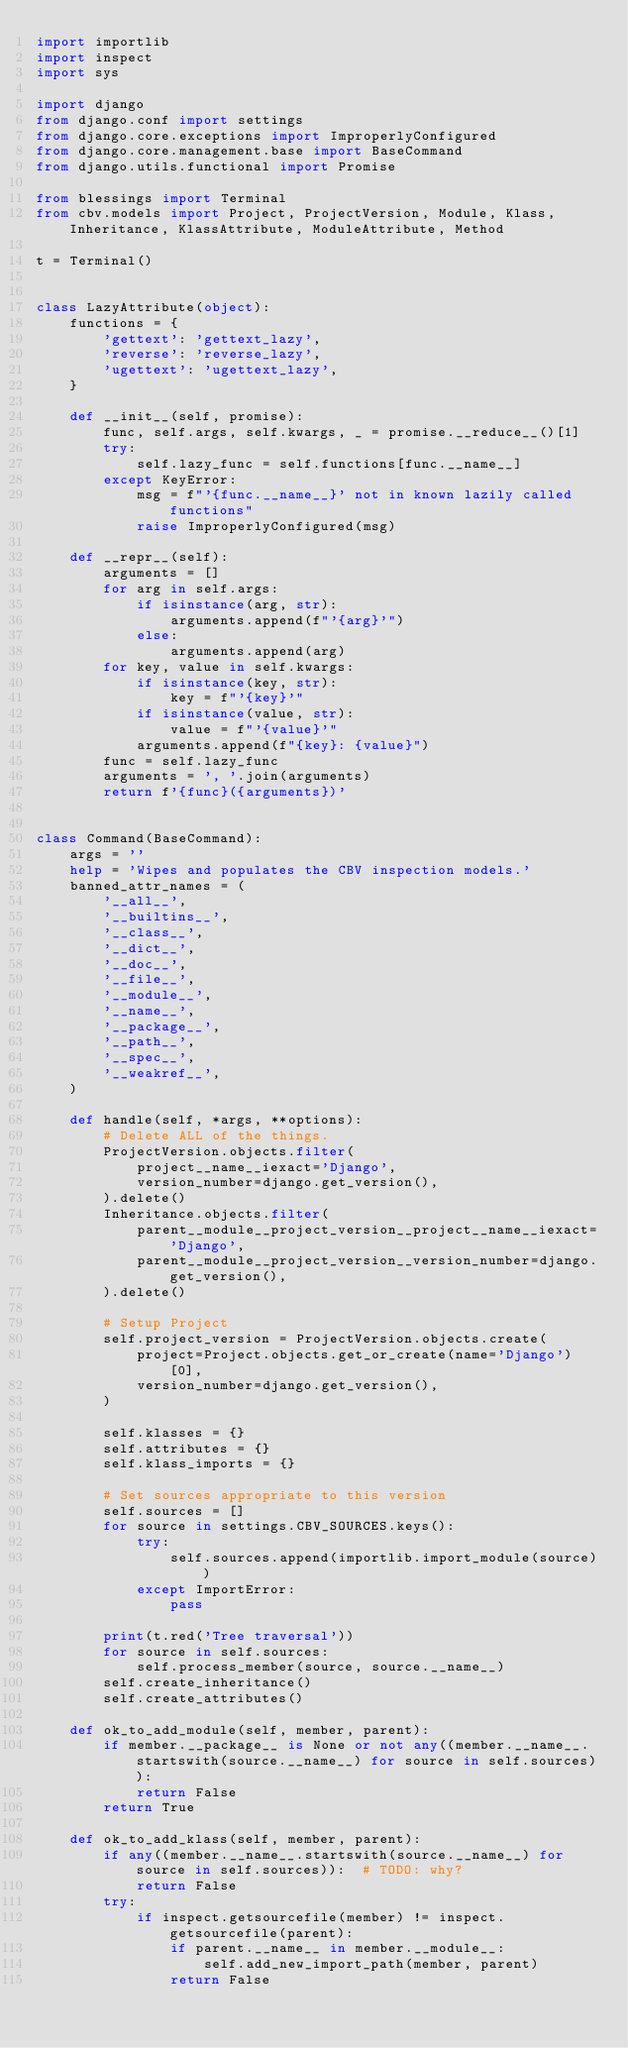<code> <loc_0><loc_0><loc_500><loc_500><_Python_>import importlib
import inspect
import sys

import django
from django.conf import settings
from django.core.exceptions import ImproperlyConfigured
from django.core.management.base import BaseCommand
from django.utils.functional import Promise

from blessings import Terminal
from cbv.models import Project, ProjectVersion, Module, Klass, Inheritance, KlassAttribute, ModuleAttribute, Method

t = Terminal()


class LazyAttribute(object):
    functions = {
        'gettext': 'gettext_lazy',
        'reverse': 'reverse_lazy',
        'ugettext': 'ugettext_lazy',
    }

    def __init__(self, promise):
        func, self.args, self.kwargs, _ = promise.__reduce__()[1]
        try:
            self.lazy_func = self.functions[func.__name__]
        except KeyError:
            msg = f"'{func.__name__}' not in known lazily called functions"
            raise ImproperlyConfigured(msg)

    def __repr__(self):
        arguments = []
        for arg in self.args:
            if isinstance(arg, str):
                arguments.append(f"'{arg}'")
            else:
                arguments.append(arg)
        for key, value in self.kwargs:
            if isinstance(key, str):
                key = f"'{key}'"
            if isinstance(value, str):
                value = f"'{value}'"
            arguments.append(f"{key}: {value}")
        func = self.lazy_func
        arguments = ', '.join(arguments)
        return f'{func}({arguments})'


class Command(BaseCommand):
    args = ''
    help = 'Wipes and populates the CBV inspection models.'
    banned_attr_names = (
        '__all__',
        '__builtins__',
        '__class__',
        '__dict__',
        '__doc__',
        '__file__',
        '__module__',
        '__name__',
        '__package__',
        '__path__',
        '__spec__',
        '__weakref__',
    )

    def handle(self, *args, **options):
        # Delete ALL of the things.
        ProjectVersion.objects.filter(
            project__name__iexact='Django',
            version_number=django.get_version(),
        ).delete()
        Inheritance.objects.filter(
            parent__module__project_version__project__name__iexact='Django',
            parent__module__project_version__version_number=django.get_version(),
        ).delete()

        # Setup Project
        self.project_version = ProjectVersion.objects.create(
            project=Project.objects.get_or_create(name='Django')[0],
            version_number=django.get_version(),
        )

        self.klasses = {}
        self.attributes = {}
        self.klass_imports = {}

        # Set sources appropriate to this version
        self.sources = []
        for source in settings.CBV_SOURCES.keys():
            try:
                self.sources.append(importlib.import_module(source))
            except ImportError:
                pass

        print(t.red('Tree traversal'))
        for source in self.sources:
            self.process_member(source, source.__name__)
        self.create_inheritance()
        self.create_attributes()

    def ok_to_add_module(self, member, parent):
        if member.__package__ is None or not any((member.__name__.startswith(source.__name__) for source in self.sources)):
            return False
        return True

    def ok_to_add_klass(self, member, parent):
        if any((member.__name__.startswith(source.__name__) for source in self.sources)):  # TODO: why?
            return False
        try:
            if inspect.getsourcefile(member) != inspect.getsourcefile(parent):
                if parent.__name__ in member.__module__:
                    self.add_new_import_path(member, parent)
                return False</code> 